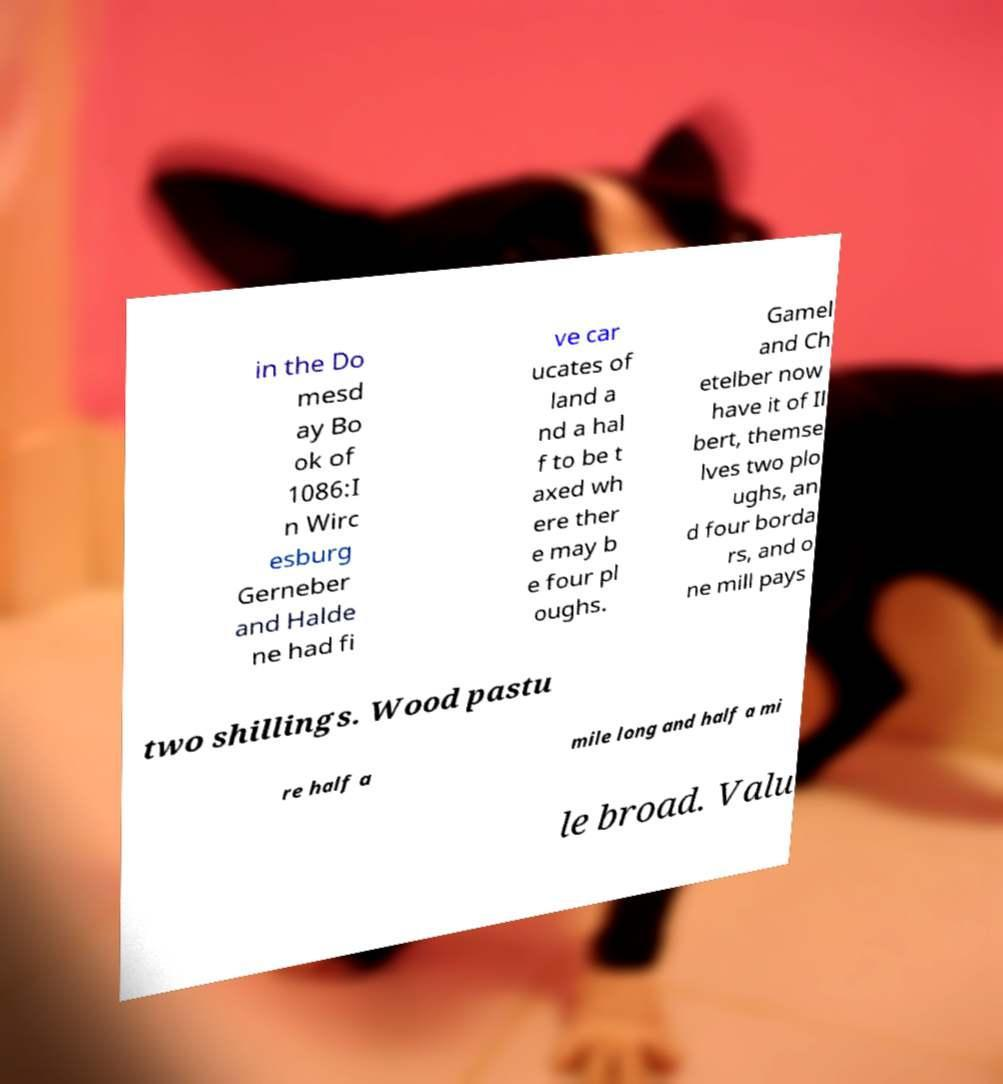Please identify and transcribe the text found in this image. in the Do mesd ay Bo ok of 1086:I n Wirc esburg Gerneber and Halde ne had fi ve car ucates of land a nd a hal f to be t axed wh ere ther e may b e four pl oughs. Gamel and Ch etelber now have it of Il bert, themse lves two plo ughs, an d four borda rs, and o ne mill pays two shillings. Wood pastu re half a mile long and half a mi le broad. Valu 